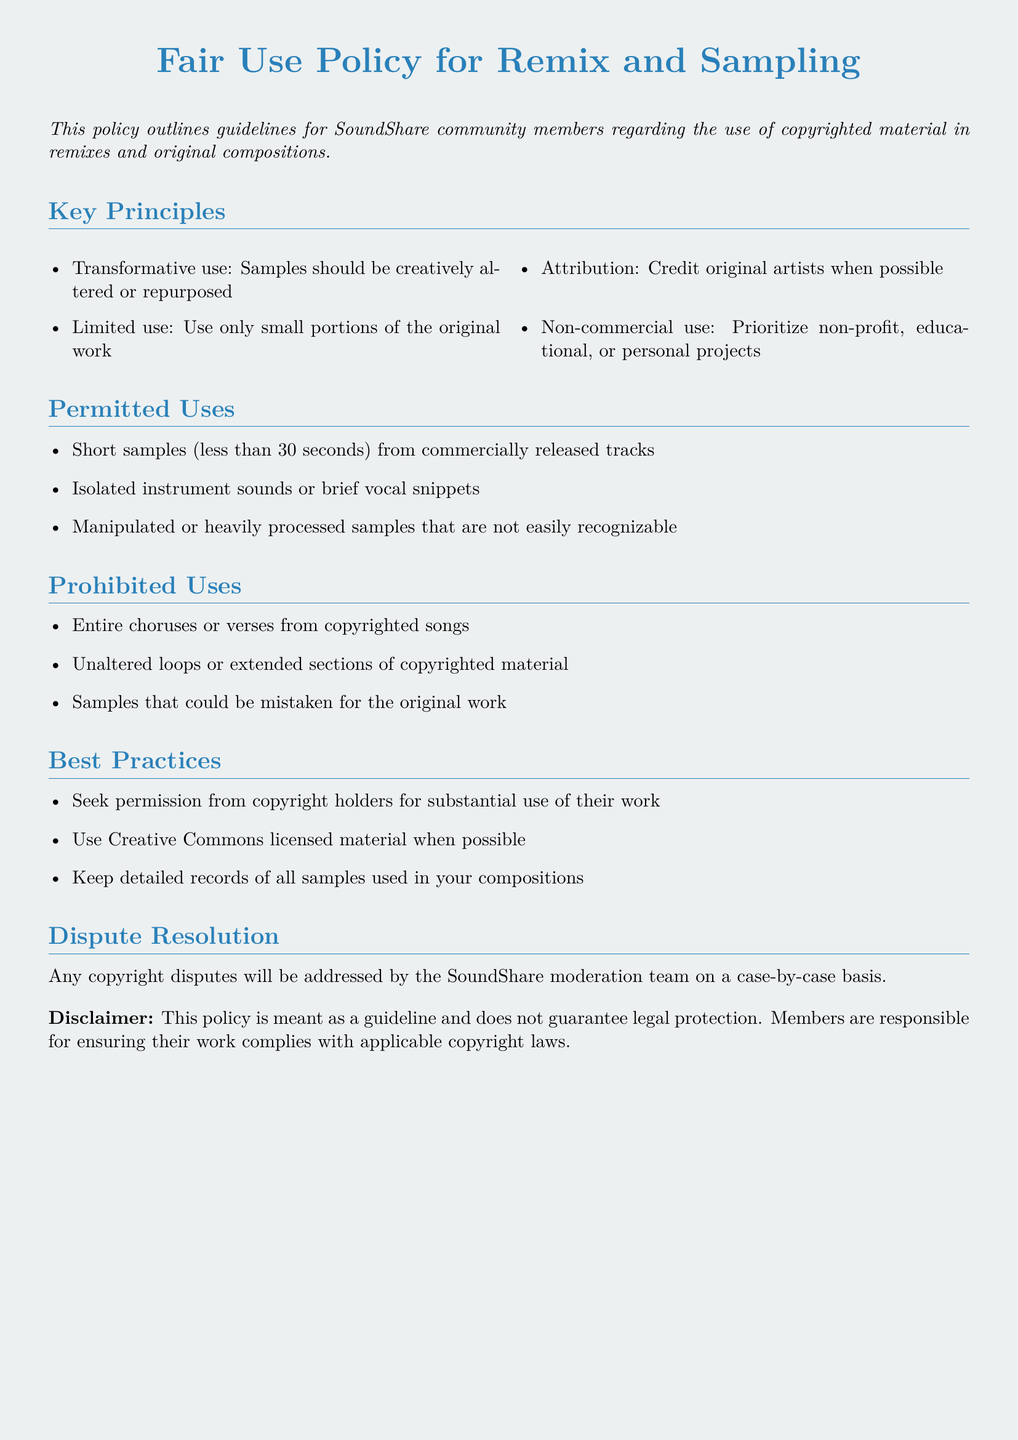What is this document about? The document outlines guidelines for the community regarding the use of copyrighted material in remixes and original compositions.
Answer: Fair Use Policy for Remix and Sampling What are the key principles of the policy? The key principles are listed in the document and include transformative use, limited use, attribution, and non-commercial use.
Answer: Transformative use, Limited use, Attribution, Non-commercial use How long can permitted short samples be? The document specifies the maximum length for permitted short samples in remixes and original compositions.
Answer: Less than 30 seconds What should members do regarding copyright disputes? The document explains how disputes will be addressed within the community and who will handle them.
Answer: SoundShare moderation team What is a prohibited use in the policy? The document contains a list of specific actions that are not allowed under the policy regarding sampling and remixing works.
Answer: Entire choruses or verses from copyrighted songs 